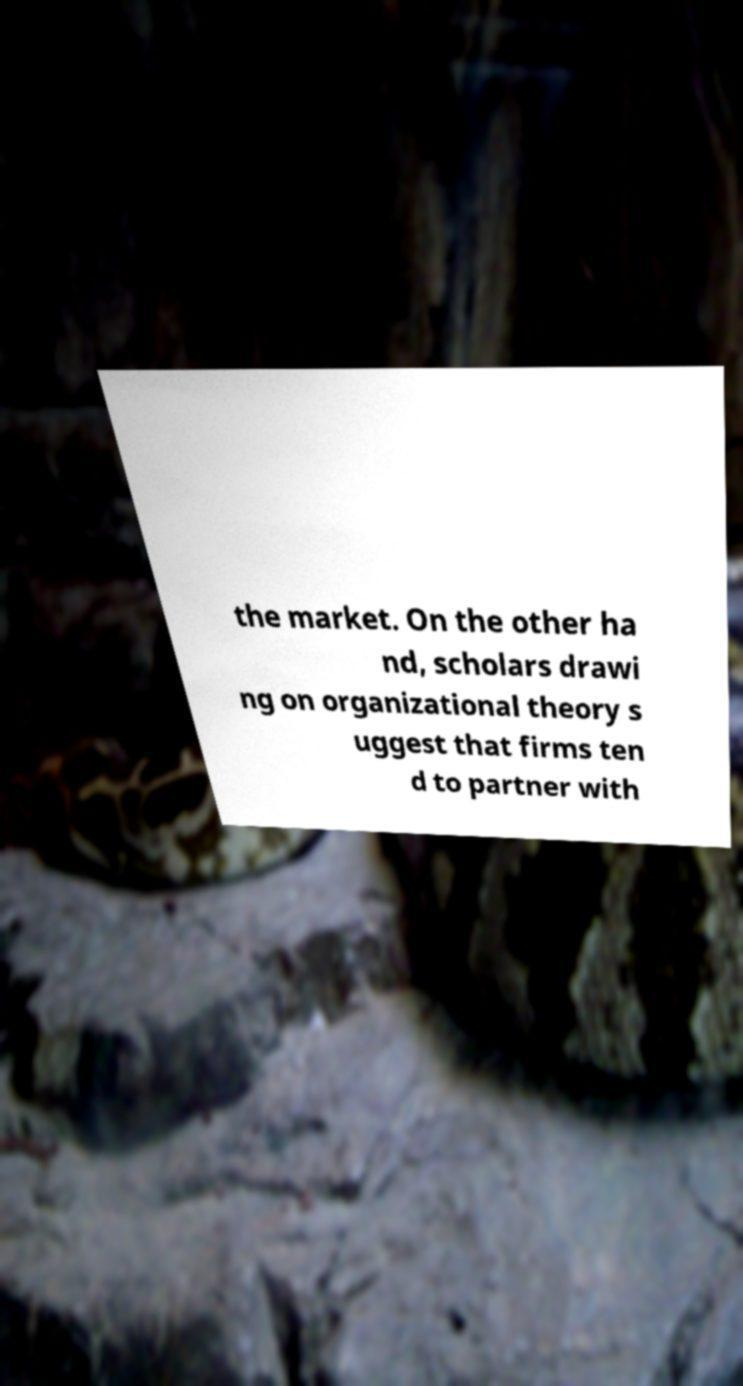Can you read and provide the text displayed in the image?This photo seems to have some interesting text. Can you extract and type it out for me? the market. On the other ha nd, scholars drawi ng on organizational theory s uggest that firms ten d to partner with 